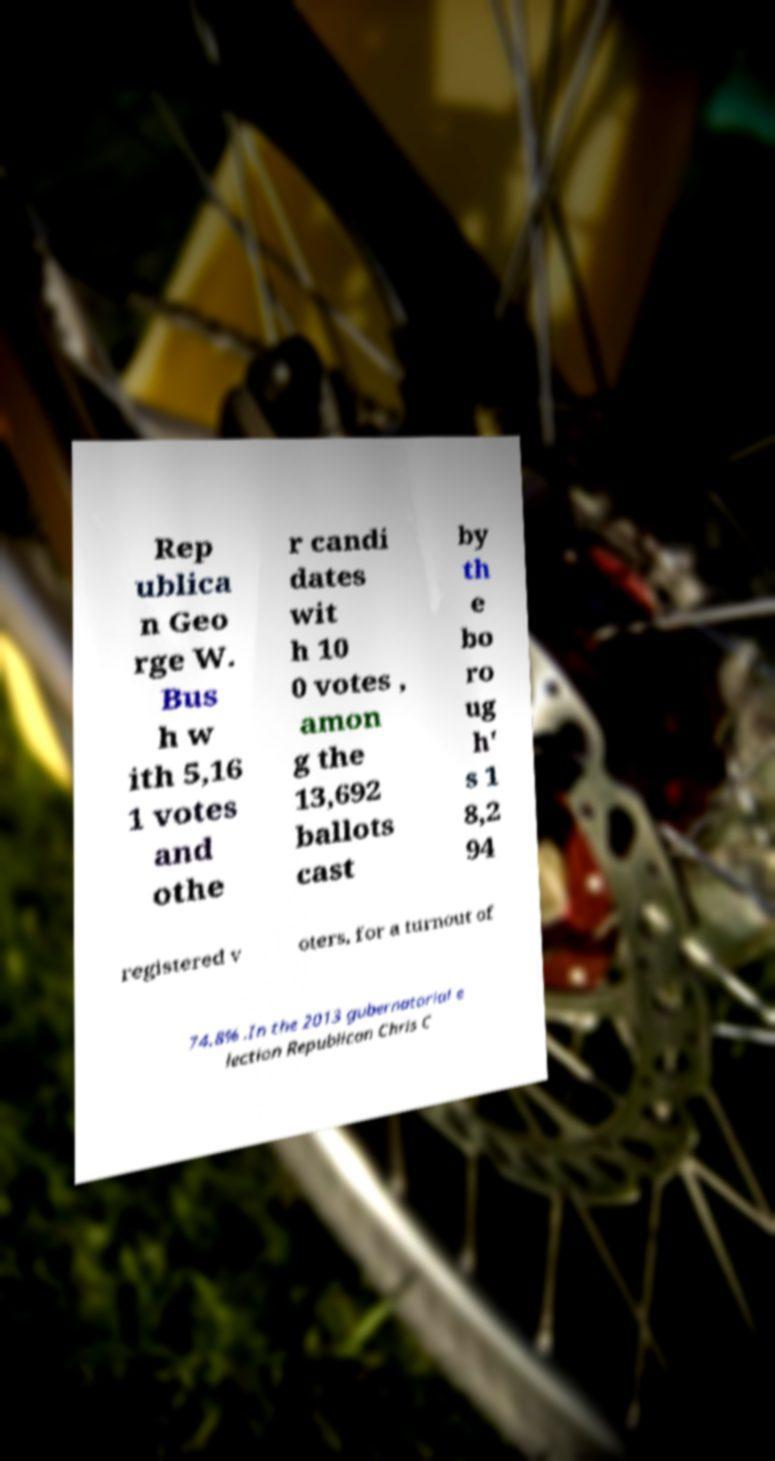I need the written content from this picture converted into text. Can you do that? Rep ublica n Geo rge W. Bus h w ith 5,16 1 votes and othe r candi dates wit h 10 0 votes , amon g the 13,692 ballots cast by th e bo ro ug h' s 1 8,2 94 registered v oters, for a turnout of 74.8% .In the 2013 gubernatorial e lection Republican Chris C 